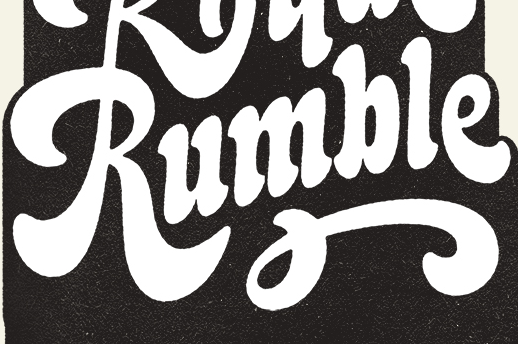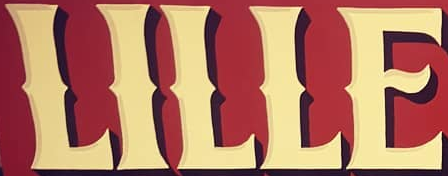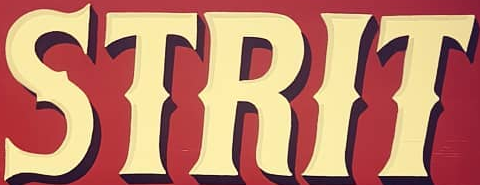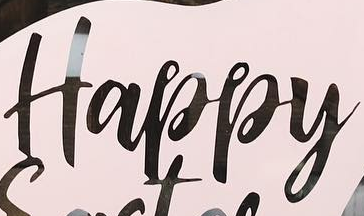Read the text content from these images in order, separated by a semicolon. Rumble; LILLE; STRIT; Happy 